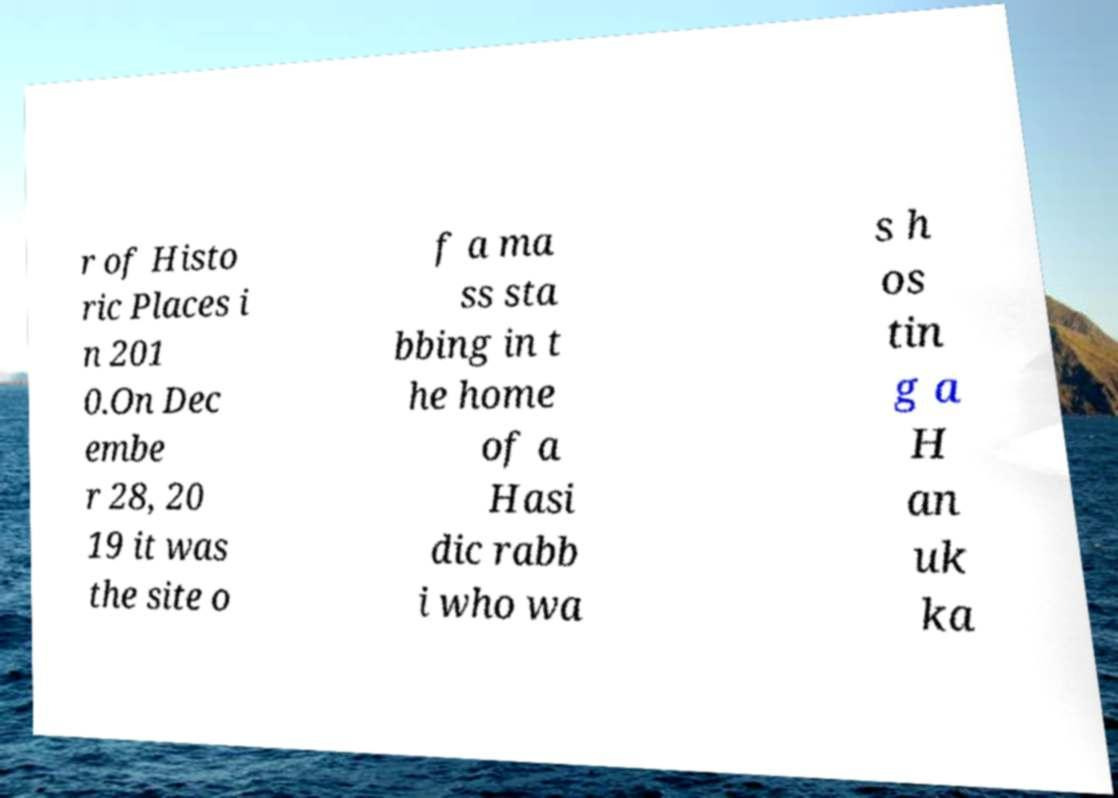What messages or text are displayed in this image? I need them in a readable, typed format. r of Histo ric Places i n 201 0.On Dec embe r 28, 20 19 it was the site o f a ma ss sta bbing in t he home of a Hasi dic rabb i who wa s h os tin g a H an uk ka 